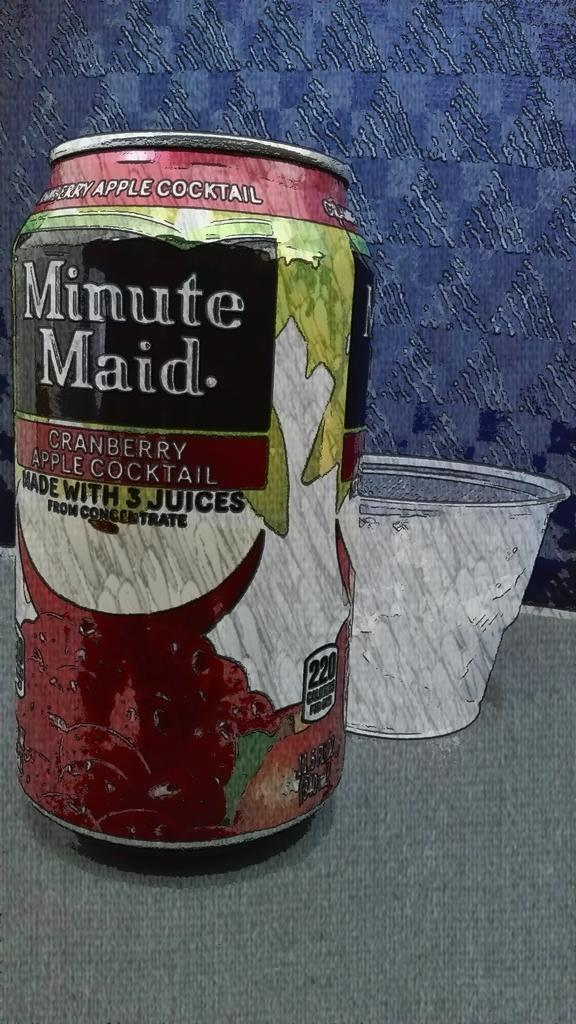<image>
Offer a succinct explanation of the picture presented. A Minute Maid cranberry cocktail can and a plastic cup behind it. 